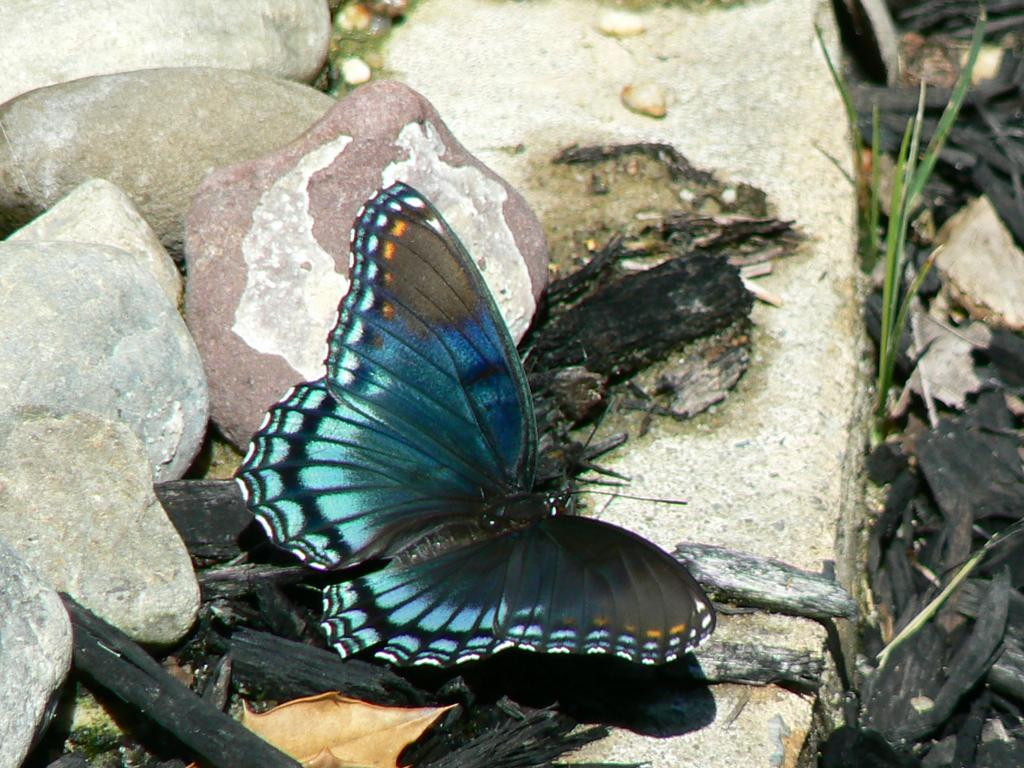What type of insect is present in the image? There is a blue butterfly in the image. What type of vegetation can be seen in the image? There is grass in the image. What color are the objects in the image? The objects in the image are black. What type of natural elements can be seen in the image? There are stones in the image. What type of crime is being committed in the image? There is no crime being committed in the image; it features a blue butterfly, grass, black objects, and stones. Can you see an airplane in the image? No, there is no airplane present in the image. 